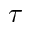<formula> <loc_0><loc_0><loc_500><loc_500>\tau</formula> 